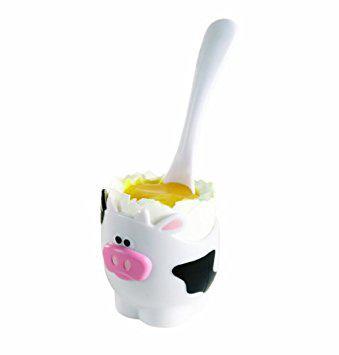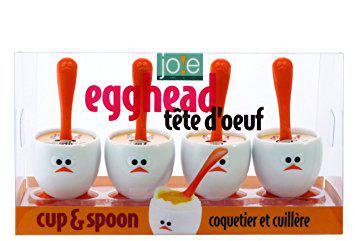The first image is the image on the left, the second image is the image on the right. For the images shown, is this caption "One image shows a spoon inserted in yolk in the egg-shaped cup with orange feet." true? Answer yes or no. No. 